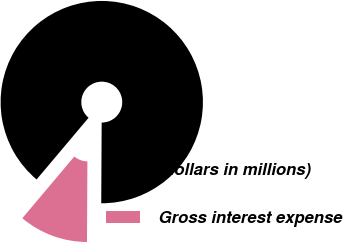Convert chart to OTSL. <chart><loc_0><loc_0><loc_500><loc_500><pie_chart><fcel>(dollars in millions)<fcel>Gross interest expense<nl><fcel>88.94%<fcel>11.06%<nl></chart> 